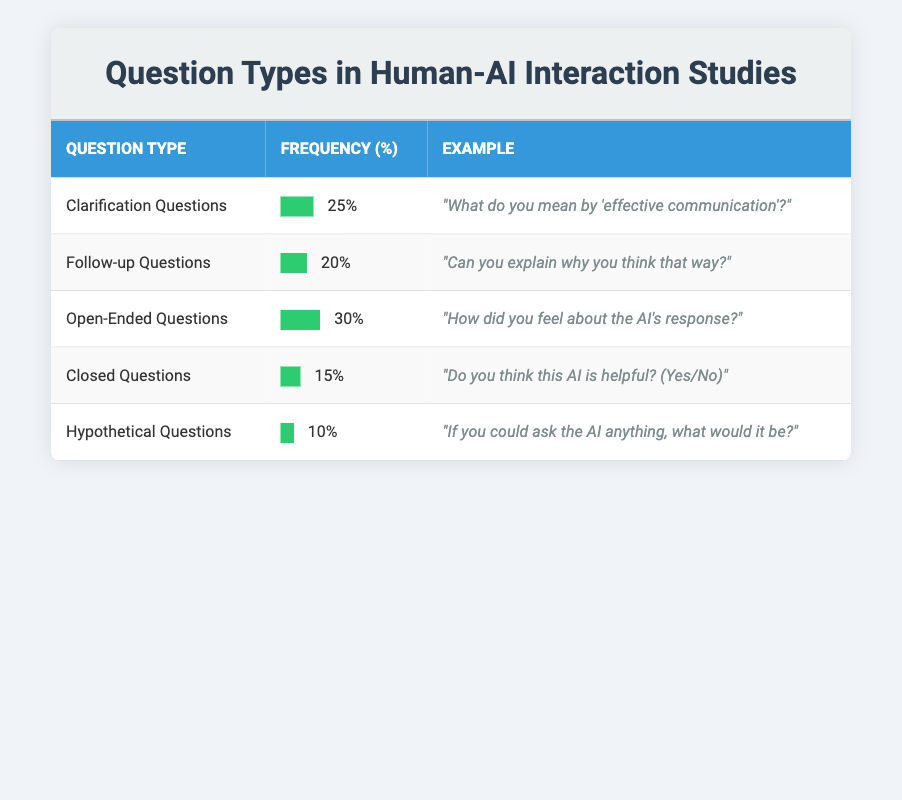What is the highest frequency of question types recorded in the table? The question types are listed with their respective frequencies: Clarification Questions (25%), Follow-up Questions (20%), Open-Ended Questions (30%), Closed Questions (15%), and Hypothetical Questions (10%). Among these, Open-Ended Questions have the highest frequency at 30%.
Answer: 30% What is the percentage frequency of Closed Questions? The frequency of Closed Questions is directly stated in the table as 15%.
Answer: 15% Which question type has the lowest frequency? By comparing the frequencies listed in the table, Hypothetical Questions have the lowest frequency at 10%, which is less than the other question types.
Answer: Hypothetical Questions What is the total frequency percentage of Clarification Questions and Follow-up Questions combined? The frequency of Clarification Questions is 25% and Follow-up Questions is 20%. Adding these together gives 25% + 20% = 45%.
Answer: 45% Are there more Open-Ended Questions than Follow-up Questions? The frequency of Open-Ended Questions is 30% while Follow-up Questions have a frequency of 20%. Since 30% is greater than 20%, the statement is true.
Answer: Yes What percentage of participants used either Clarification or Closed Questions? Clarification Questions had a frequency of 25% and Closed Questions had a frequency of 15%. Summing these gives 25% + 15% = 40%.
Answer: 40% If we rank the question types by frequency, what would be the second highest? The frequencies in descending order are: Open-Ended Questions (30%), Clarification Questions (25%), Follow-up Questions (20%), Closed Questions (15%), and Hypothetical Questions (10%). Therefore, the second highest is Clarification Questions at 25%.
Answer: Clarification Questions What percentage of participant questions were not Hypothetical Questions? Hypothetical Questions account for 10% of the total frequencies. To find the percentage of questions that were not Hypothetical Questions, we subtract 10% from 100%, resulting in 90%.
Answer: 90% 